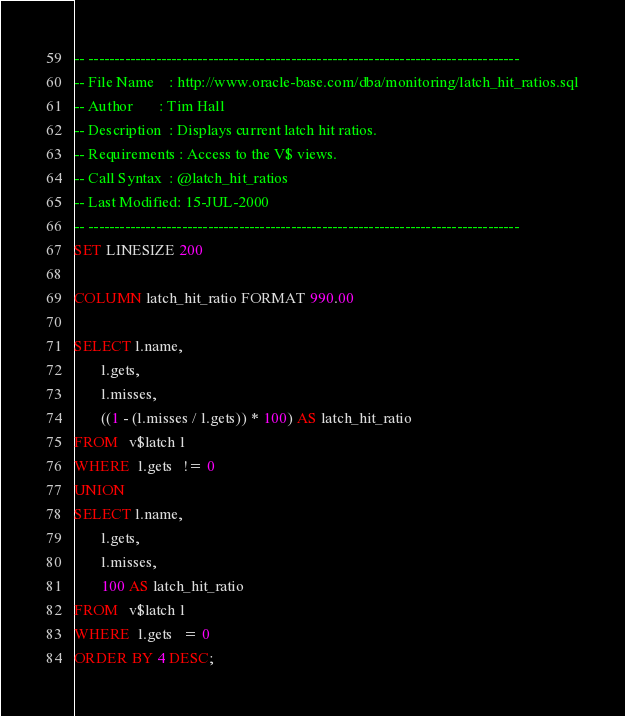<code> <loc_0><loc_0><loc_500><loc_500><_SQL_>-- -----------------------------------------------------------------------------------
-- File Name    : http://www.oracle-base.com/dba/monitoring/latch_hit_ratios.sql
-- Author       : Tim Hall
-- Description  : Displays current latch hit ratios.
-- Requirements : Access to the V$ views.
-- Call Syntax  : @latch_hit_ratios
-- Last Modified: 15-JUL-2000
-- -----------------------------------------------------------------------------------
SET LINESIZE 200

COLUMN latch_hit_ratio FORMAT 990.00
 
SELECT l.name,
       l.gets,
       l.misses,
       ((1 - (l.misses / l.gets)) * 100) AS latch_hit_ratio
FROM   v$latch l
WHERE  l.gets   != 0
UNION
SELECT l.name,
       l.gets,
       l.misses,
       100 AS latch_hit_ratio
FROM   v$latch l
WHERE  l.gets   = 0
ORDER BY 4 DESC;
</code> 